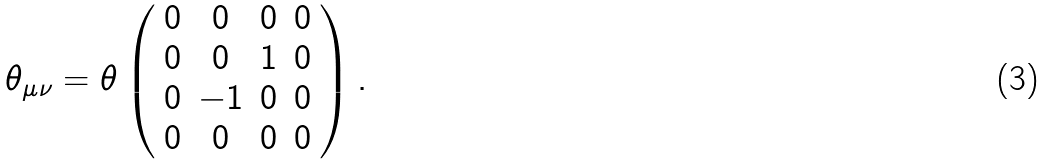Convert formula to latex. <formula><loc_0><loc_0><loc_500><loc_500>\theta _ { \mu \nu } = \theta \left ( \begin{array} { c c c c } 0 & 0 & 0 & 0 \\ 0 & 0 & 1 & 0 \\ 0 & - 1 & 0 & 0 \\ 0 & 0 & 0 & 0 \end{array} \right ) .</formula> 